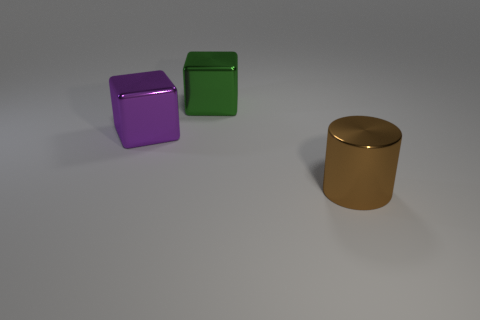Add 3 small gray metallic objects. How many objects exist? 6 Subtract all cubes. How many objects are left? 1 Add 2 large shiny things. How many large shiny things are left? 5 Add 2 large blue metal balls. How many large blue metal balls exist? 2 Subtract 0 blue balls. How many objects are left? 3 Subtract all big metallic objects. Subtract all gray cylinders. How many objects are left? 0 